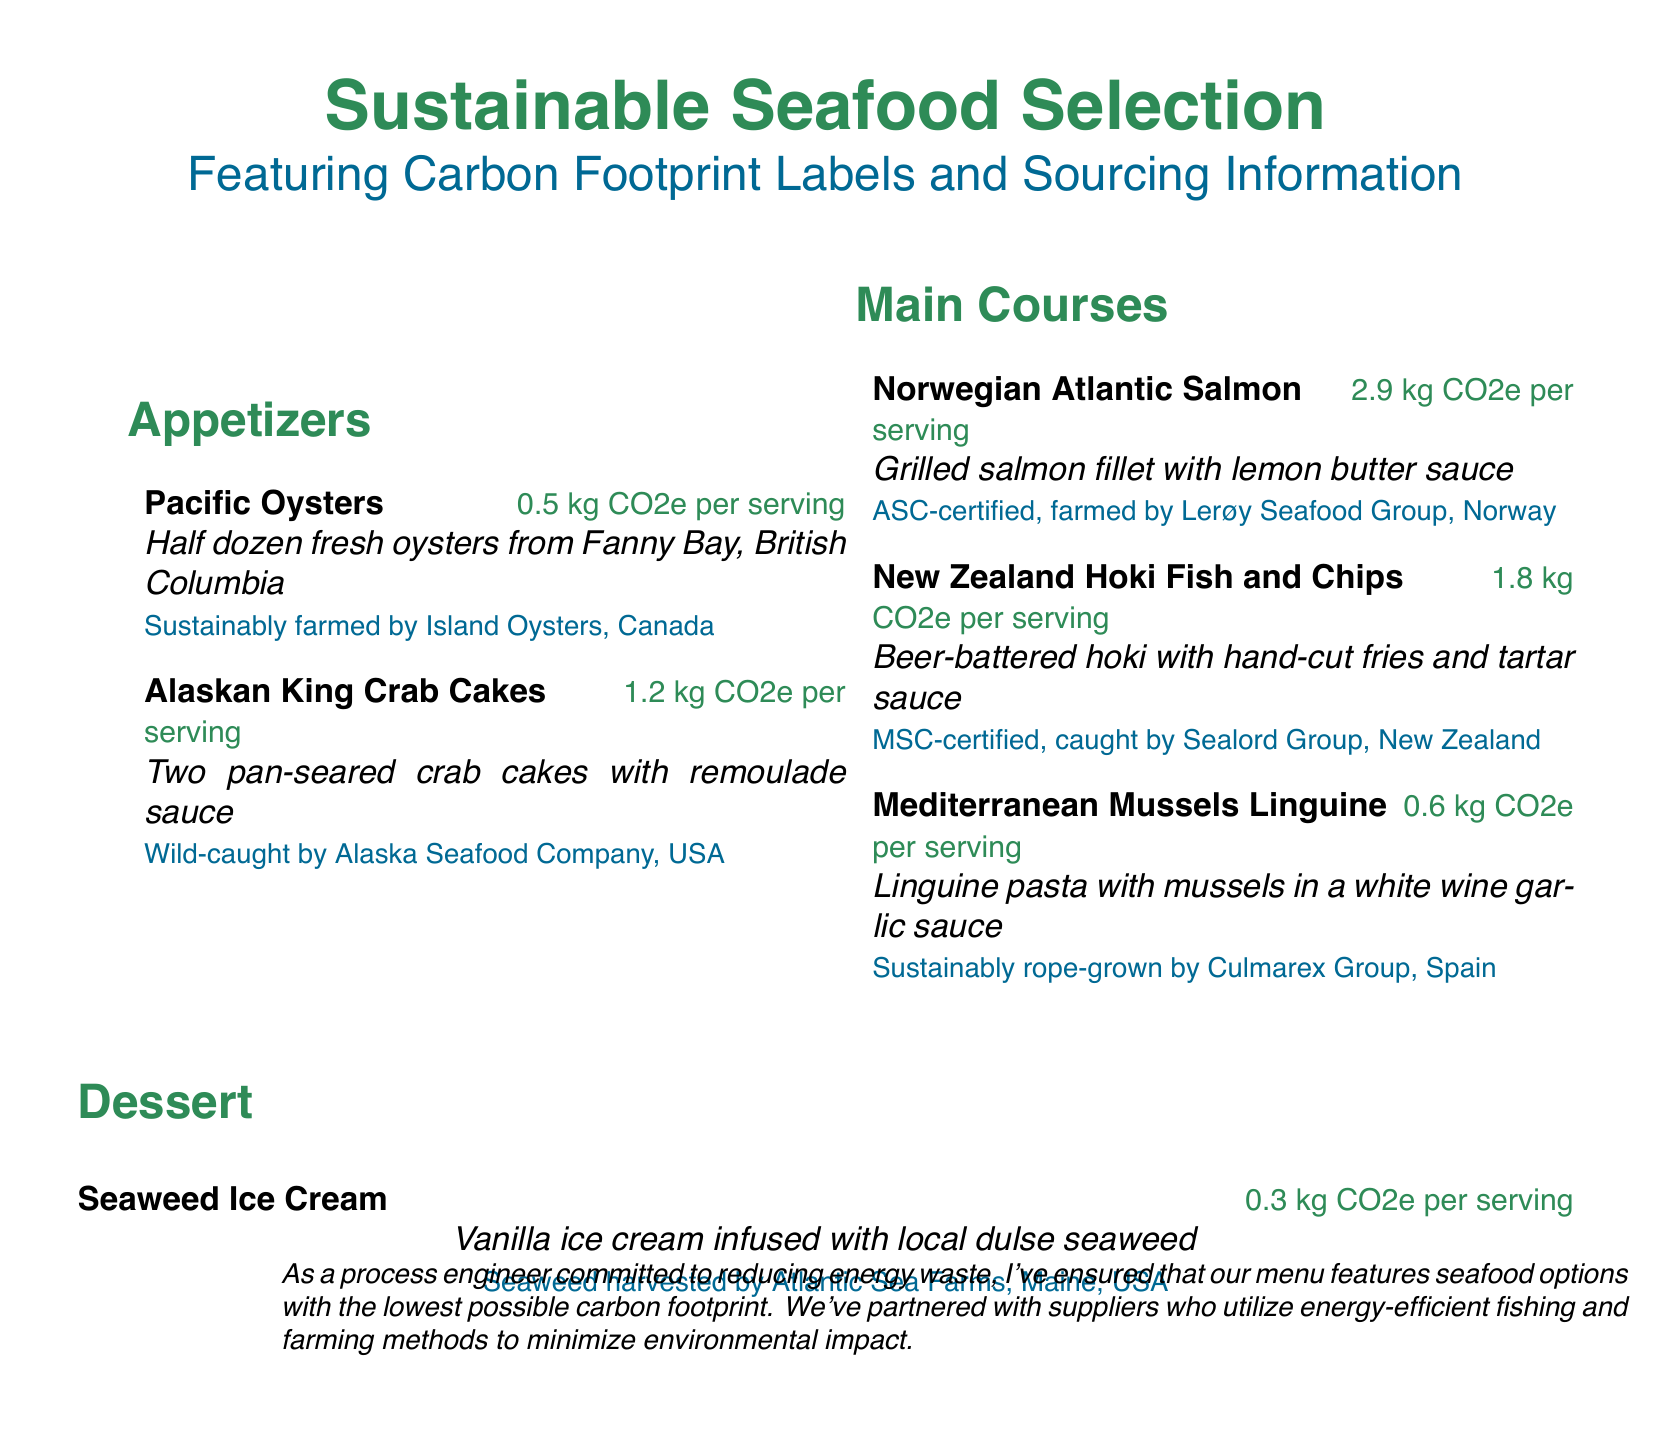What is the carbon footprint of Pacific Oysters? The carbon footprint of Pacific Oysters is listed as 0.5 kg CO2e per serving.
Answer: 0.5 kg CO2e per serving Which supplier sustainably farms the Norwegian Atlantic Salmon? The document states that the Norwegian Atlantic Salmon is ASC-certified and farmed by Lerøy Seafood Group, Norway.
Answer: Lerøy Seafood Group, Norway How many crab cakes are served in the Alaskan King Crab Cakes dish? The Alaskan King Crab Cakes dish includes two pan-seared crab cakes.
Answer: Two What type of certification does the New Zealand Hoki Fish and Chips have? The New Zealand Hoki Fish and Chips is MSC-certified, indicating a sustainable sourcing certification.
Answer: MSC-certified Which dessert features local dulse seaweed? The dessert featuring local dulse seaweed is Seaweed Ice Cream.
Answer: Seaweed Ice Cream What is the carbon footprint for the Mediterranean Mussels Linguine? The Mediterranean Mussels Linguine has a carbon footprint of 0.6 kg CO2e per serving.
Answer: 0.6 kg CO2e per serving From which region are the Pacific Oysters sourced? The Pacific Oysters are sourced from Fanny Bay, British Columbia.
Answer: Fanny Bay, British Columbia What is the total carbon footprint of the appetizers listed? The total carbon footprint is calculated by adding the carbon footprints of both appetizers: 0.5 kg + 1.2 kg = 1.7 kg CO2e per serving.
Answer: 1.7 kg CO2e per serving 